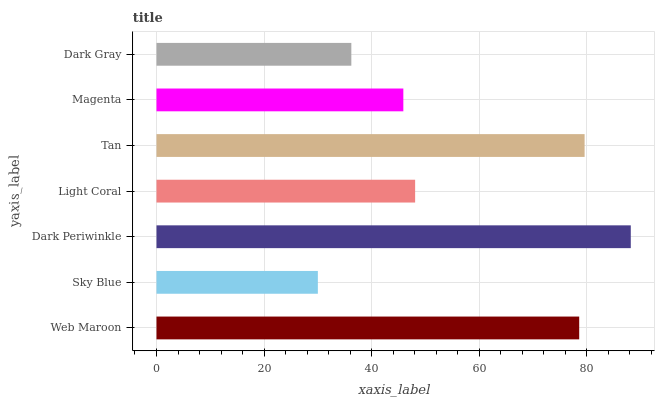Is Sky Blue the minimum?
Answer yes or no. Yes. Is Dark Periwinkle the maximum?
Answer yes or no. Yes. Is Dark Periwinkle the minimum?
Answer yes or no. No. Is Sky Blue the maximum?
Answer yes or no. No. Is Dark Periwinkle greater than Sky Blue?
Answer yes or no. Yes. Is Sky Blue less than Dark Periwinkle?
Answer yes or no. Yes. Is Sky Blue greater than Dark Periwinkle?
Answer yes or no. No. Is Dark Periwinkle less than Sky Blue?
Answer yes or no. No. Is Light Coral the high median?
Answer yes or no. Yes. Is Light Coral the low median?
Answer yes or no. Yes. Is Tan the high median?
Answer yes or no. No. Is Magenta the low median?
Answer yes or no. No. 